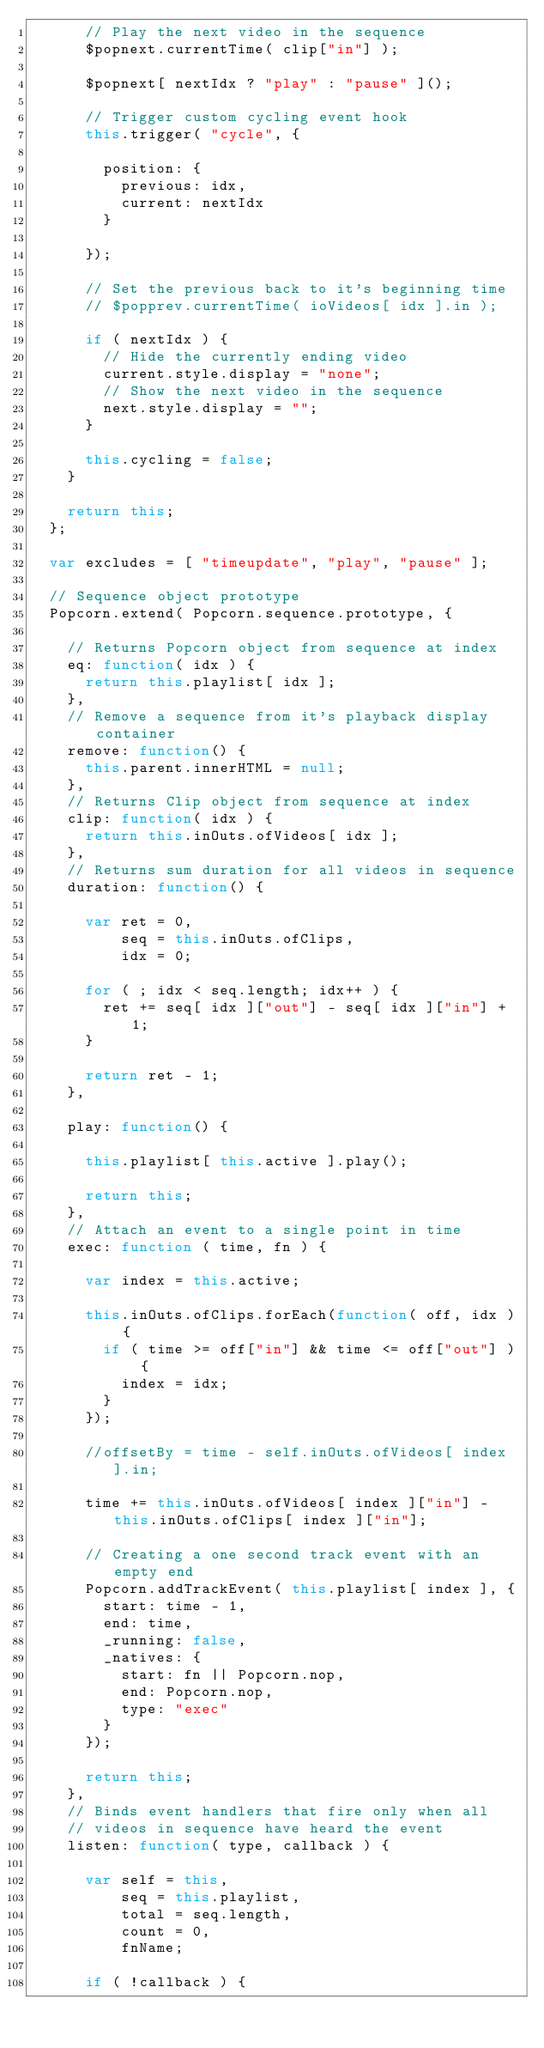Convert code to text. <code><loc_0><loc_0><loc_500><loc_500><_JavaScript_>      // Play the next video in the sequence
      $popnext.currentTime( clip["in"] );

      $popnext[ nextIdx ? "play" : "pause" ]();

      // Trigger custom cycling event hook
      this.trigger( "cycle", {

        position: {
          previous: idx,
          current: nextIdx
        }

      });

      // Set the previous back to it's beginning time
      // $popprev.currentTime( ioVideos[ idx ].in );

      if ( nextIdx ) {
        // Hide the currently ending video
        current.style.display = "none";
        // Show the next video in the sequence
        next.style.display = "";
      }

      this.cycling = false;
    }

    return this;
  };

  var excludes = [ "timeupdate", "play", "pause" ];

  // Sequence object prototype
  Popcorn.extend( Popcorn.sequence.prototype, {

    // Returns Popcorn object from sequence at index
    eq: function( idx ) {
      return this.playlist[ idx ];
    },
    // Remove a sequence from it's playback display container
    remove: function() {
      this.parent.innerHTML = null;
    },
    // Returns Clip object from sequence at index
    clip: function( idx ) {
      return this.inOuts.ofVideos[ idx ];
    },
    // Returns sum duration for all videos in sequence
    duration: function() {

      var ret = 0,
          seq = this.inOuts.ofClips,
          idx = 0;

      for ( ; idx < seq.length; idx++ ) {
        ret += seq[ idx ]["out"] - seq[ idx ]["in"] + 1;
      }

      return ret - 1;
    },

    play: function() {

      this.playlist[ this.active ].play();

      return this;
    },
    // Attach an event to a single point in time
    exec: function ( time, fn ) {

      var index = this.active;

      this.inOuts.ofClips.forEach(function( off, idx ) {
        if ( time >= off["in"] && time <= off["out"] ) {
          index = idx;
        }
      });

      //offsetBy = time - self.inOuts.ofVideos[ index ].in;

      time += this.inOuts.ofVideos[ index ]["in"] - this.inOuts.ofClips[ index ]["in"];

      // Creating a one second track event with an empty end
      Popcorn.addTrackEvent( this.playlist[ index ], {
        start: time - 1,
        end: time,
        _running: false,
        _natives: {
          start: fn || Popcorn.nop,
          end: Popcorn.nop,
          type: "exec"
        }
      });

      return this;
    },
    // Binds event handlers that fire only when all
    // videos in sequence have heard the event
    listen: function( type, callback ) {

      var self = this,
          seq = this.playlist,
          total = seq.length,
          count = 0,
          fnName;

      if ( !callback ) {</code> 